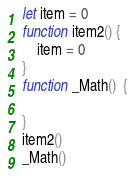Convert code to text. <code><loc_0><loc_0><loc_500><loc_500><_TypeScript_>let item = 0
function item2() {
    item = 0
}
function _Math()  {
	
}
item2()
_Math()
</code> 